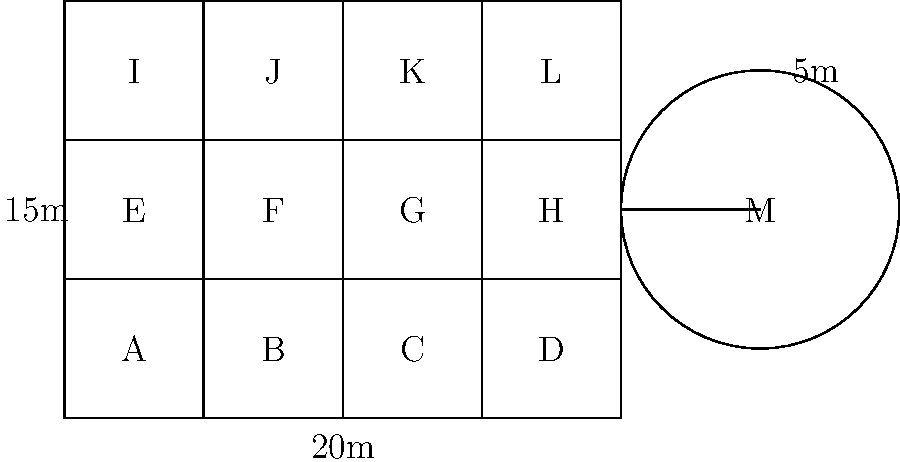A new research facility in South Africa consists of a rectangular main building divided into 12 equal-sized rooms (labeled A through L) and a circular laboratory (M) connected by a corridor. The main building measures 20m by 15m, and the circular lab has a radius of 5m. Calculate the total floor area of the research facility, including the circular lab but excluding the connecting corridor. Round your answer to the nearest square meter. Let's break this down step-by-step:

1. Calculate the area of the main building:
   $A_{main} = 20m \times 15m = 300m^2$

2. Calculate the area of the circular lab:
   $A_{circle} = \pi r^2 = \pi \times (5m)^2 = 25\pi m^2$

3. Add the two areas:
   $A_{total} = A_{main} + A_{circle} = 300m^2 + 25\pi m^2$

4. Simplify and calculate:
   $A_{total} = 300m^2 + 25 \times 3.14159... m^2$
   $A_{total} = 300m^2 + 78.54m^2$
   $A_{total} = 378.54m^2$

5. Round to the nearest square meter:
   $A_{total} \approx 379m^2$
Answer: 379 m² 